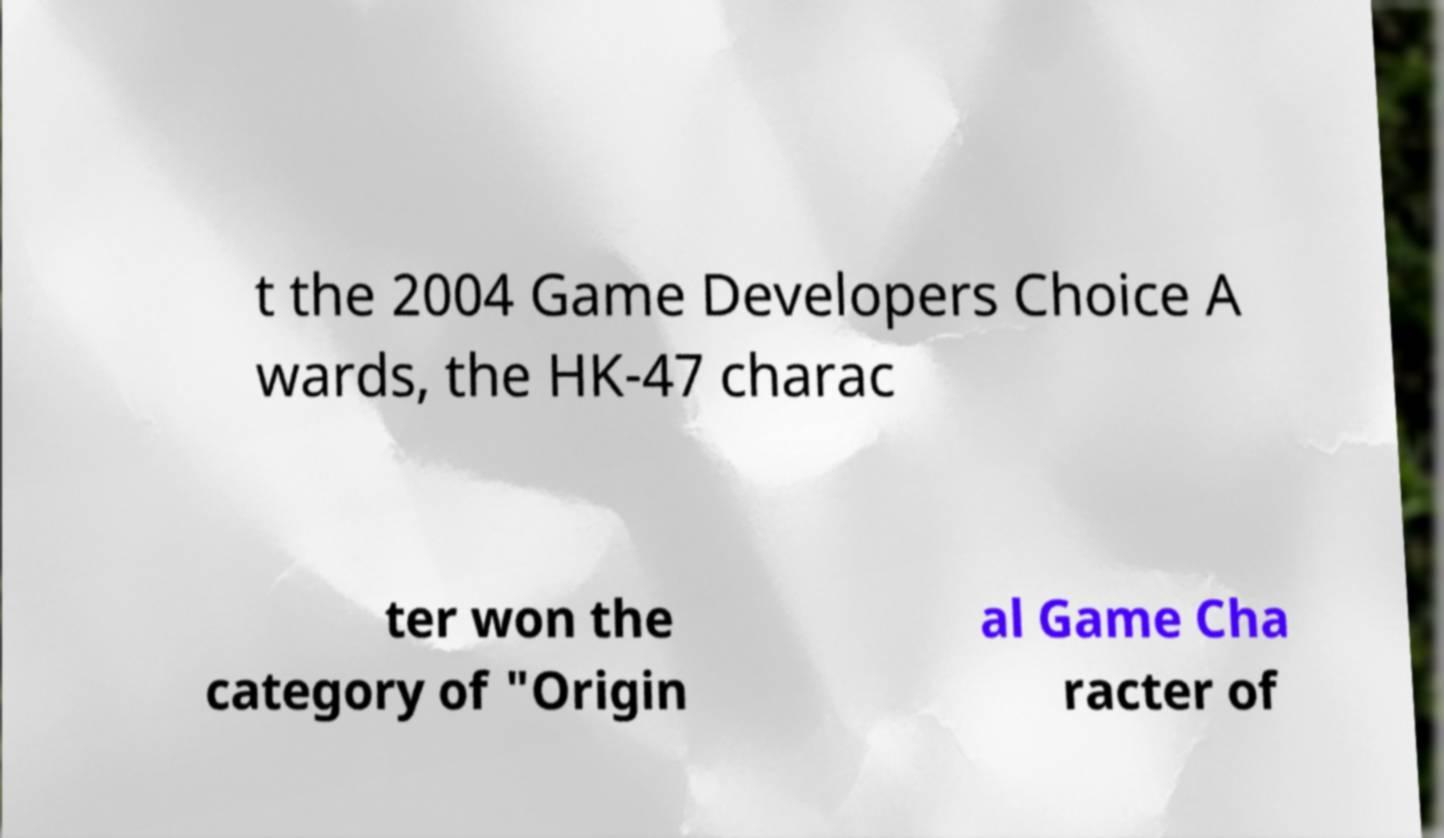Can you read and provide the text displayed in the image?This photo seems to have some interesting text. Can you extract and type it out for me? t the 2004 Game Developers Choice A wards, the HK-47 charac ter won the category of "Origin al Game Cha racter of 